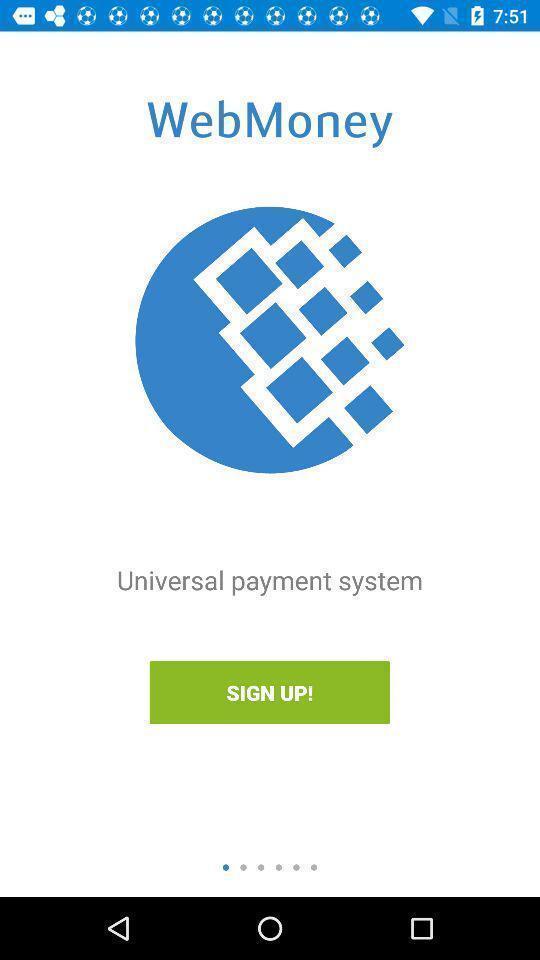Provide a textual representation of this image. Welcome page for a payment application. 